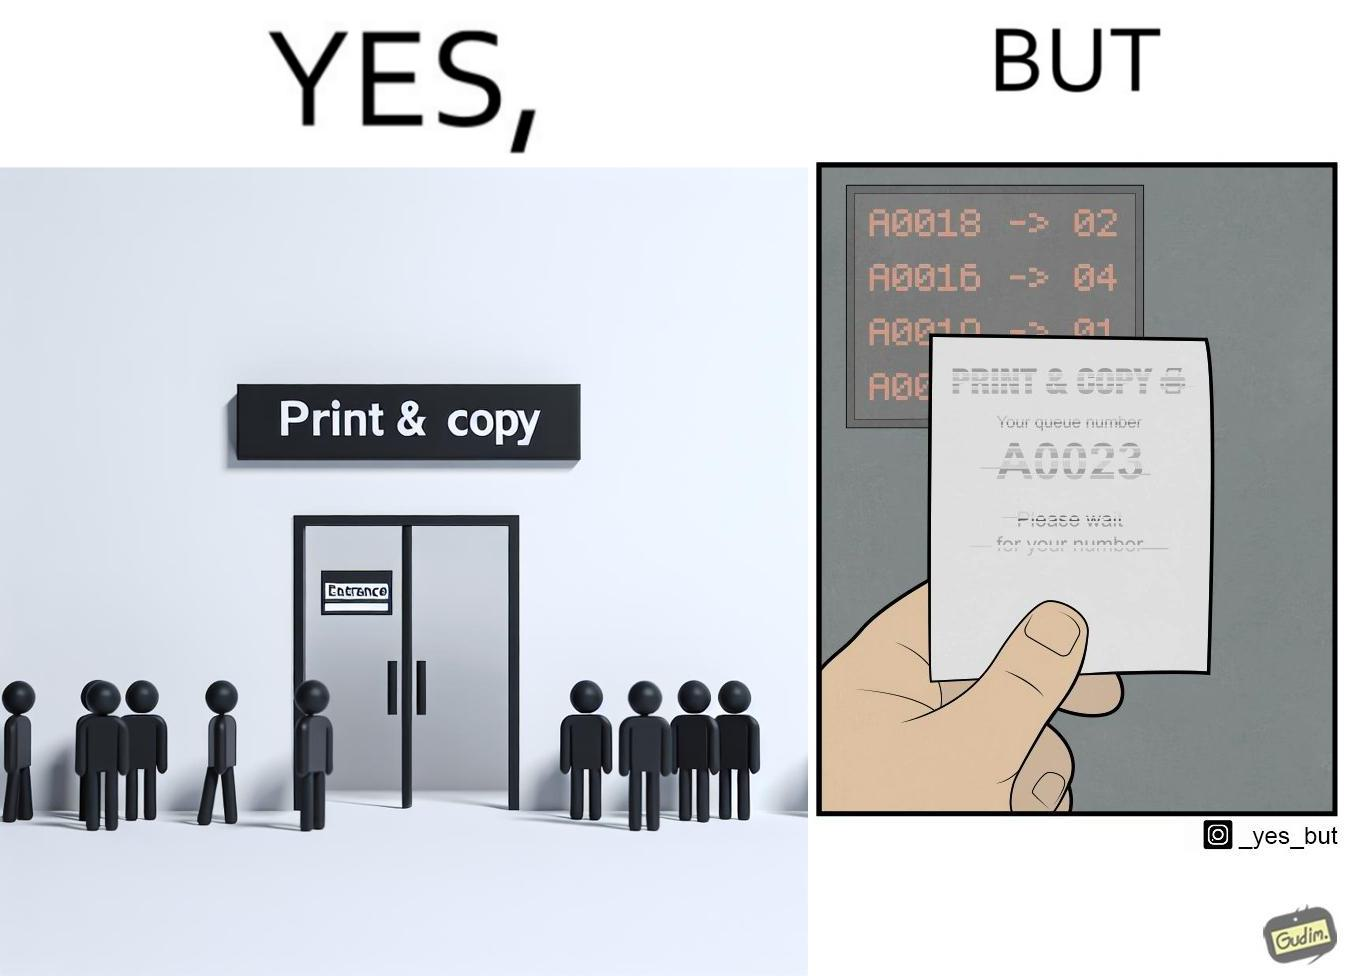Is this image satirical or non-satirical? Yes, this image is satirical. 